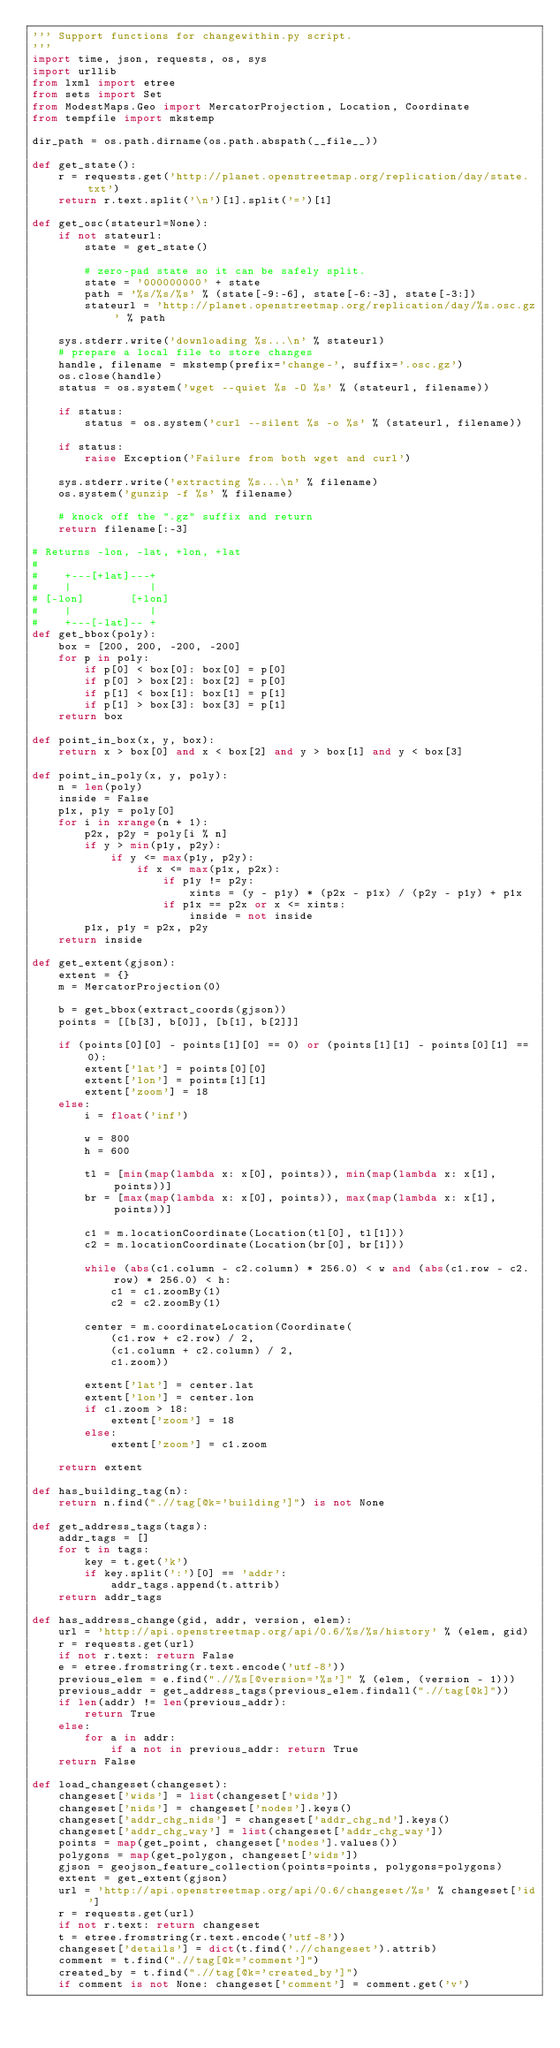Convert code to text. <code><loc_0><loc_0><loc_500><loc_500><_Python_>''' Support functions for changewithin.py script.
'''
import time, json, requests, os, sys
import urllib
from lxml import etree
from sets import Set
from ModestMaps.Geo import MercatorProjection, Location, Coordinate
from tempfile import mkstemp

dir_path = os.path.dirname(os.path.abspath(__file__))

def get_state():
    r = requests.get('http://planet.openstreetmap.org/replication/day/state.txt')
    return r.text.split('\n')[1].split('=')[1]

def get_osc(stateurl=None):
    if not stateurl:
        state = get_state()

        # zero-pad state so it can be safely split.
        state = '000000000' + state
        path = '%s/%s/%s' % (state[-9:-6], state[-6:-3], state[-3:])
        stateurl = 'http://planet.openstreetmap.org/replication/day/%s.osc.gz' % path

    sys.stderr.write('downloading %s...\n' % stateurl)
    # prepare a local file to store changes
    handle, filename = mkstemp(prefix='change-', suffix='.osc.gz')
    os.close(handle)
    status = os.system('wget --quiet %s -O %s' % (stateurl, filename))

    if status:
        status = os.system('curl --silent %s -o %s' % (stateurl, filename))
    
    if status:
        raise Exception('Failure from both wget and curl')
    
    sys.stderr.write('extracting %s...\n' % filename)
    os.system('gunzip -f %s' % filename)

    # knock off the ".gz" suffix and return
    return filename[:-3]

# Returns -lon, -lat, +lon, +lat
#
#    +---[+lat]---+
#    |            |
# [-lon]       [+lon]
#    |            |
#    +---[-lat]-- +
def get_bbox(poly):
    box = [200, 200, -200, -200]
    for p in poly:
        if p[0] < box[0]: box[0] = p[0]
        if p[0] > box[2]: box[2] = p[0]
        if p[1] < box[1]: box[1] = p[1]
        if p[1] > box[3]: box[3] = p[1]
    return box

def point_in_box(x, y, box):
    return x > box[0] and x < box[2] and y > box[1] and y < box[3]

def point_in_poly(x, y, poly):
    n = len(poly)
    inside = False
    p1x, p1y = poly[0]
    for i in xrange(n + 1):
        p2x, p2y = poly[i % n]
        if y > min(p1y, p2y):
            if y <= max(p1y, p2y):
                if x <= max(p1x, p2x):
                    if p1y != p2y:
                        xints = (y - p1y) * (p2x - p1x) / (p2y - p1y) + p1x
                    if p1x == p2x or x <= xints:
                        inside = not inside
        p1x, p1y = p2x, p2y
    return inside

def get_extent(gjson):
    extent = {}
    m = MercatorProjection(0)

    b = get_bbox(extract_coords(gjson))
    points = [[b[3], b[0]], [b[1], b[2]]]

    if (points[0][0] - points[1][0] == 0) or (points[1][1] - points[0][1] == 0):
        extent['lat'] = points[0][0]
        extent['lon'] = points[1][1]
        extent['zoom'] = 18
    else:
        i = float('inf')
         
        w = 800
        h = 600
         
        tl = [min(map(lambda x: x[0], points)), min(map(lambda x: x[1], points))]
        br = [max(map(lambda x: x[0], points)), max(map(lambda x: x[1], points))]
         
        c1 = m.locationCoordinate(Location(tl[0], tl[1]))
        c2 = m.locationCoordinate(Location(br[0], br[1]))
         
        while (abs(c1.column - c2.column) * 256.0) < w and (abs(c1.row - c2.row) * 256.0) < h:
            c1 = c1.zoomBy(1)
            c2 = c2.zoomBy(1)
         
        center = m.coordinateLocation(Coordinate(
            (c1.row + c2.row) / 2,
            (c1.column + c2.column) / 2,
            c1.zoom))
        
        extent['lat'] = center.lat
        extent['lon'] = center.lon
        if c1.zoom > 18:
            extent['zoom'] = 18
        else:
            extent['zoom'] = c1.zoom
        
    return extent

def has_building_tag(n):
    return n.find(".//tag[@k='building']") is not None
    
def get_address_tags(tags):
    addr_tags = []
    for t in tags:
        key = t.get('k')
        if key.split(':')[0] == 'addr':
            addr_tags.append(t.attrib)
    return addr_tags
    
def has_address_change(gid, addr, version, elem):
    url = 'http://api.openstreetmap.org/api/0.6/%s/%s/history' % (elem, gid)
    r = requests.get(url)
    if not r.text: return False
    e = etree.fromstring(r.text.encode('utf-8'))
    previous_elem = e.find(".//%s[@version='%s']" % (elem, (version - 1)))
    previous_addr = get_address_tags(previous_elem.findall(".//tag[@k]"))
    if len(addr) != len(previous_addr):
        return True
    else:
        for a in addr:
            if a not in previous_addr: return True
    return False

def load_changeset(changeset):
    changeset['wids'] = list(changeset['wids'])
    changeset['nids'] = changeset['nodes'].keys()
    changeset['addr_chg_nids'] = changeset['addr_chg_nd'].keys()
    changeset['addr_chg_way'] = list(changeset['addr_chg_way'])
    points = map(get_point, changeset['nodes'].values())
    polygons = map(get_polygon, changeset['wids'])
    gjson = geojson_feature_collection(points=points, polygons=polygons)
    extent = get_extent(gjson)
    url = 'http://api.openstreetmap.org/api/0.6/changeset/%s' % changeset['id']
    r = requests.get(url)
    if not r.text: return changeset
    t = etree.fromstring(r.text.encode('utf-8'))
    changeset['details'] = dict(t.find('.//changeset').attrib)
    comment = t.find(".//tag[@k='comment']")
    created_by = t.find(".//tag[@k='created_by']")
    if comment is not None: changeset['comment'] = comment.get('v')</code> 